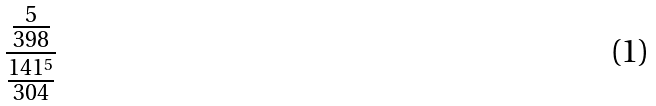Convert formula to latex. <formula><loc_0><loc_0><loc_500><loc_500>\frac { \frac { 5 } { 3 9 8 } } { \frac { 1 4 1 ^ { 5 } } { 3 0 4 } }</formula> 